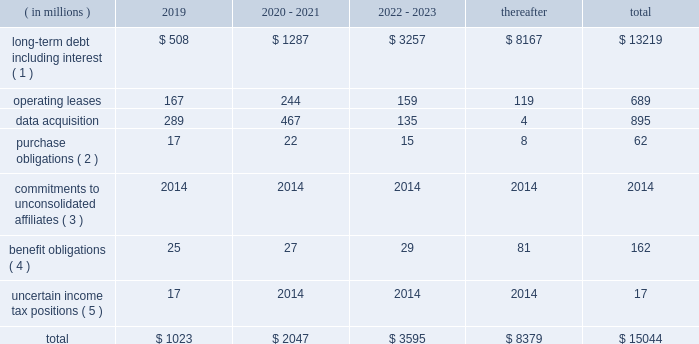Contingencies we are exposed to certain known contingencies that are material to our investors .
The facts and circumstances surrounding these contingencies and a discussion of their effect on us are in note 12 to our audited consolidated financial statements included elsewhere in this annual report on form 10-k .
These contingencies may have a material effect on our liquidity , capital resources or results of operations .
In addition , even where our reserves are adequate , the incurrence of any of these liabilities may have a material effect on our liquidity and the amount of cash available to us for other purposes .
We believe that we have made appropriate arrangements in respect of the future effect on us of these known contingencies .
We also believe that the amount of cash available to us from our operations , together with cash from financing , will be sufficient for us to pay any known contingencies as they become due without materially affecting our ability to conduct our operations and invest in the growth of our business .
Off-balance sheet arrangements we do not have any off-balance sheet arrangements except for operating leases entered into in the normal course of business .
Contractual obligations and commitments below is a summary of our future payment commitments by year under contractual obligations as of december 31 , 2018: .
( 1 ) interest payments on our debt are based on the interest rates in effect on december 31 , 2018 .
( 2 ) purchase obligations are defined as agreements to purchase goods or services that are enforceable and legally binding and that specify all significant terms , including fixed or minimum quantities to be purchased , fixed , minimum or variable pricing provisions and the approximate timing of the transactions .
( 3 ) we are currently committed to invest $ 120 million in private equity funds .
As of december 31 , 2018 , we have funded approximately $ 78 million of these commitments and we have approximately $ 42 million remaining to be funded which has not been included in the above table as we are unable to predict when these commitments will be paid .
( 4 ) amounts represent expected future benefit payments for our pension and postretirement benefit plans , as well as expected contributions for 2019 for our funded pension benefit plans .
We made cash contributions totaling approximately $ 31 million to our defined benefit plans in 2018 , and we estimate that we will make contributions totaling approximately $ 25 million to our defined benefit plans in 2019 .
Due to the potential impact of future plan investment performance , changes in interest rates , changes in other economic and demographic assumptions and changes in legislation in foreign jurisdictions , we are not able to reasonably estimate the timing and amount of contributions that may be required to fund our defined benefit plans for periods beyond 2019 .
( 5 ) as of december 31 , 2018 , our liability related to uncertain income tax positions was approximately $ 106 million , $ 89 million of which has not been included in the above table as we are unable to predict when these liabilities will be paid due to the uncertainties in the timing of the settlement of the income tax positions. .
If the remaining commitment for private equity fund was to be paid in 2019 , what would be the total commitment for 2019? 
Computations: (1023 + 42)
Answer: 1065.0. 